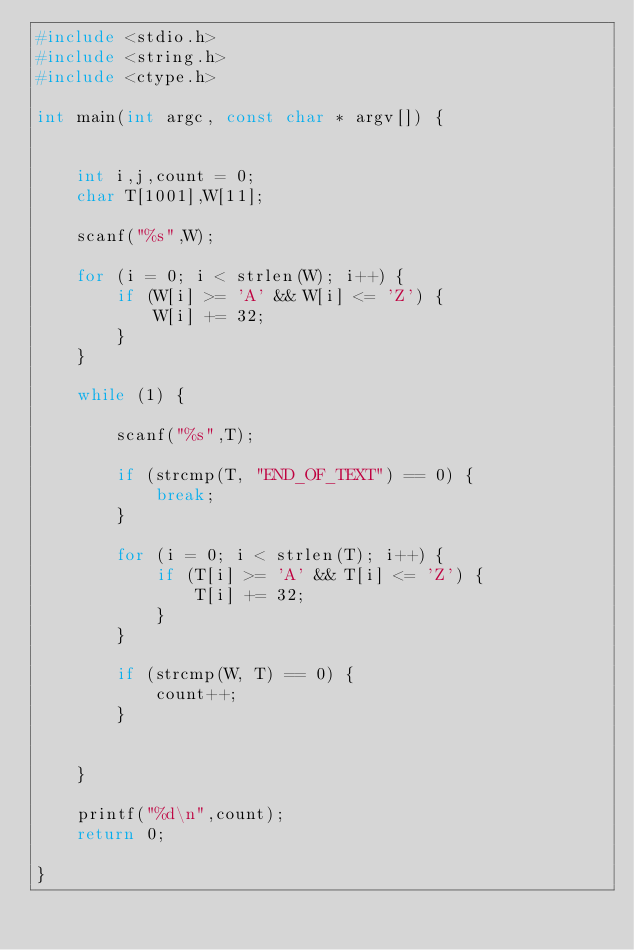<code> <loc_0><loc_0><loc_500><loc_500><_C_>#include <stdio.h>
#include <string.h>
#include <ctype.h>

int main(int argc, const char * argv[]) {
   
    
    int i,j,count = 0;
    char T[1001],W[11];
    
    scanf("%s",W);
    
    for (i = 0; i < strlen(W); i++) {
        if (W[i] >= 'A' && W[i] <= 'Z') {
            W[i] += 32;
        }
    }
    
    while (1) {
        
        scanf("%s",T);
        
        if (strcmp(T, "END_OF_TEXT") == 0) {
            break;
        }
        
        for (i = 0; i < strlen(T); i++) {
            if (T[i] >= 'A' && T[i] <= 'Z') {
                T[i] += 32;
            }
        }
        
        if (strcmp(W, T) == 0) {
            count++;
        }
        
        
    }
    
    printf("%d\n",count);
    return 0;

}</code> 